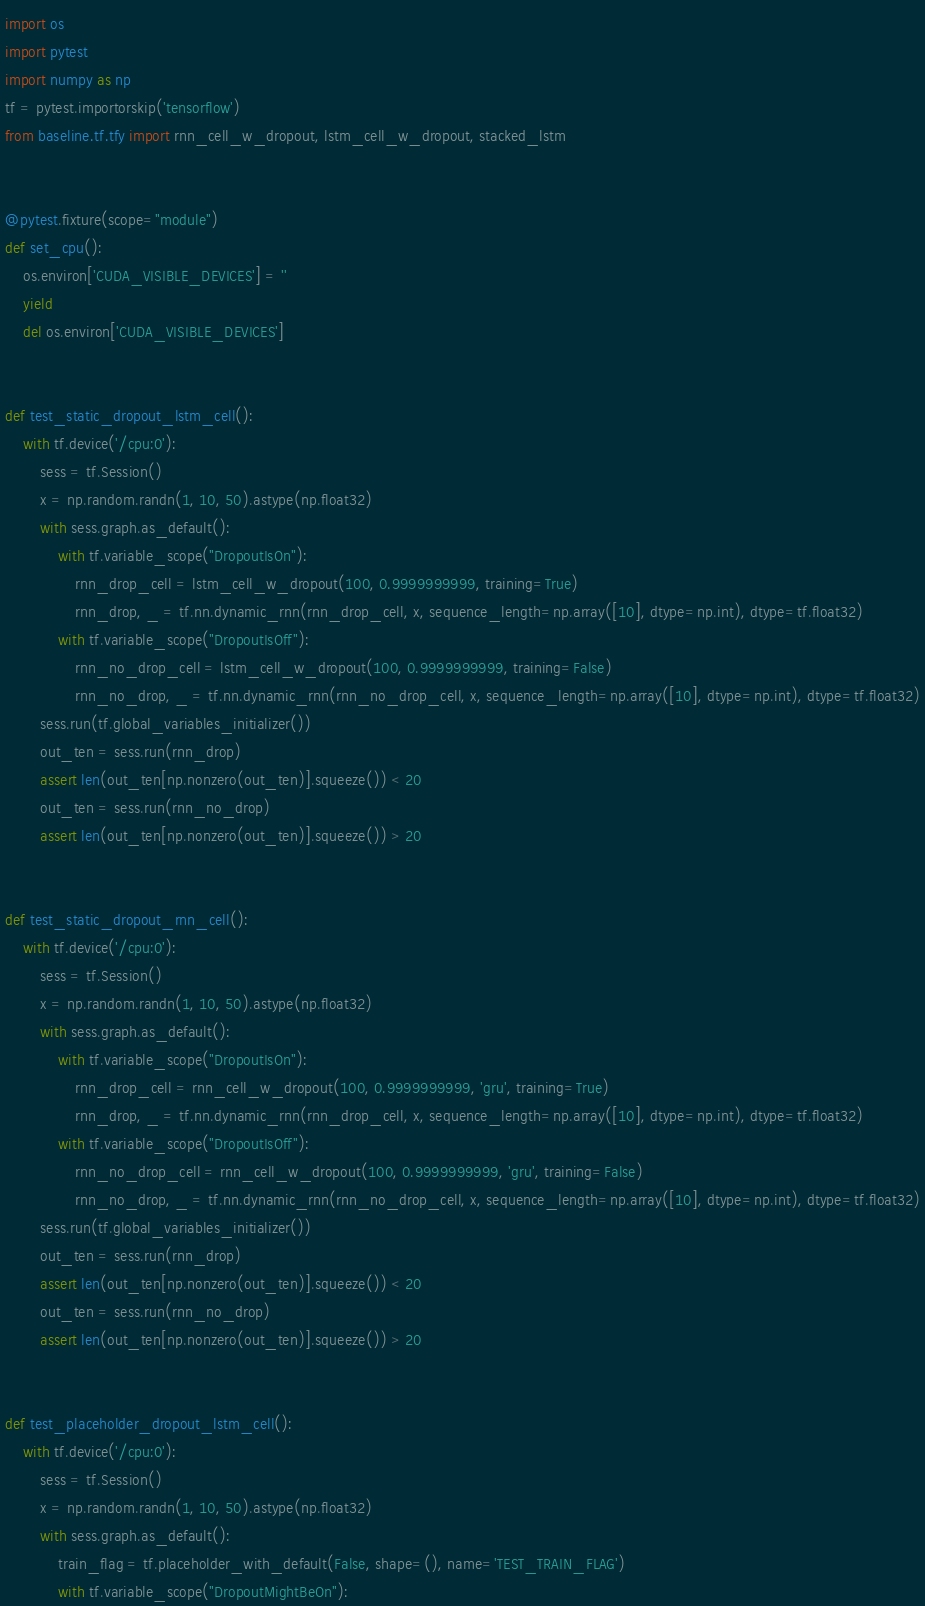Convert code to text. <code><loc_0><loc_0><loc_500><loc_500><_Python_>import os
import pytest
import numpy as np
tf = pytest.importorskip('tensorflow')
from baseline.tf.tfy import rnn_cell_w_dropout, lstm_cell_w_dropout, stacked_lstm


@pytest.fixture(scope="module")
def set_cpu():
    os.environ['CUDA_VISIBLE_DEVICES'] = ''
    yield
    del os.environ['CUDA_VISIBLE_DEVICES']


def test_static_dropout_lstm_cell():
    with tf.device('/cpu:0'):
        sess = tf.Session()
        x = np.random.randn(1, 10, 50).astype(np.float32)
        with sess.graph.as_default():
            with tf.variable_scope("DropoutIsOn"):
                rnn_drop_cell = lstm_cell_w_dropout(100, 0.9999999999, training=True)
                rnn_drop, _ = tf.nn.dynamic_rnn(rnn_drop_cell, x, sequence_length=np.array([10], dtype=np.int), dtype=tf.float32)
            with tf.variable_scope("DropoutIsOff"):
                rnn_no_drop_cell = lstm_cell_w_dropout(100, 0.9999999999, training=False)
                rnn_no_drop, _ = tf.nn.dynamic_rnn(rnn_no_drop_cell, x, sequence_length=np.array([10], dtype=np.int), dtype=tf.float32)
        sess.run(tf.global_variables_initializer())
        out_ten = sess.run(rnn_drop)
        assert len(out_ten[np.nonzero(out_ten)].squeeze()) < 20
        out_ten = sess.run(rnn_no_drop)
        assert len(out_ten[np.nonzero(out_ten)].squeeze()) > 20


def test_static_dropout_rnn_cell():
    with tf.device('/cpu:0'):
        sess = tf.Session()
        x = np.random.randn(1, 10, 50).astype(np.float32)
        with sess.graph.as_default():
            with tf.variable_scope("DropoutIsOn"):
                rnn_drop_cell = rnn_cell_w_dropout(100, 0.9999999999, 'gru', training=True)
                rnn_drop, _ = tf.nn.dynamic_rnn(rnn_drop_cell, x, sequence_length=np.array([10], dtype=np.int), dtype=tf.float32)
            with tf.variable_scope("DropoutIsOff"):
                rnn_no_drop_cell = rnn_cell_w_dropout(100, 0.9999999999, 'gru', training=False)
                rnn_no_drop, _ = tf.nn.dynamic_rnn(rnn_no_drop_cell, x, sequence_length=np.array([10], dtype=np.int), dtype=tf.float32)
        sess.run(tf.global_variables_initializer())
        out_ten = sess.run(rnn_drop)
        assert len(out_ten[np.nonzero(out_ten)].squeeze()) < 20
        out_ten = sess.run(rnn_no_drop)
        assert len(out_ten[np.nonzero(out_ten)].squeeze()) > 20


def test_placeholder_dropout_lstm_cell():
    with tf.device('/cpu:0'):
        sess = tf.Session()
        x = np.random.randn(1, 10, 50).astype(np.float32)
        with sess.graph.as_default():
            train_flag = tf.placeholder_with_default(False, shape=(), name='TEST_TRAIN_FLAG')
            with tf.variable_scope("DropoutMightBeOn"):</code> 